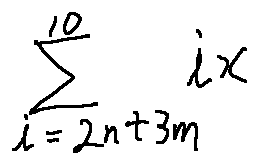Convert formula to latex. <formula><loc_0><loc_0><loc_500><loc_500>\sum \lim i t s _ { i = 2 n + 3 m } ^ { 1 0 } i x</formula> 